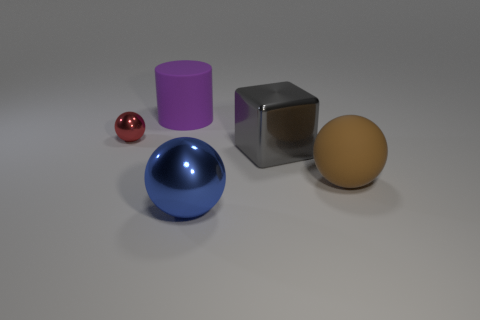There is a big sphere in front of the brown matte ball; what color is it?
Ensure brevity in your answer.  Blue. Do the large cylinder and the large shiny ball have the same color?
Keep it short and to the point. No. There is a sphere that is on the left side of the thing behind the red metal thing; what number of large purple rubber things are behind it?
Give a very brief answer. 1. What size is the gray metal block?
Provide a succinct answer. Large. There is a blue ball that is the same size as the brown thing; what material is it?
Give a very brief answer. Metal. How many large matte cylinders are in front of the brown thing?
Give a very brief answer. 0. Is the sphere that is on the left side of the big blue ball made of the same material as the large ball that is to the right of the big gray shiny block?
Your response must be concise. No. There is a large thing behind the big metallic thing to the right of the shiny ball to the right of the tiny shiny sphere; what shape is it?
Your answer should be very brief. Cylinder. What is the shape of the big purple thing?
Your answer should be very brief. Cylinder. There is a blue shiny thing that is the same size as the gray shiny cube; what shape is it?
Offer a terse response. Sphere. 